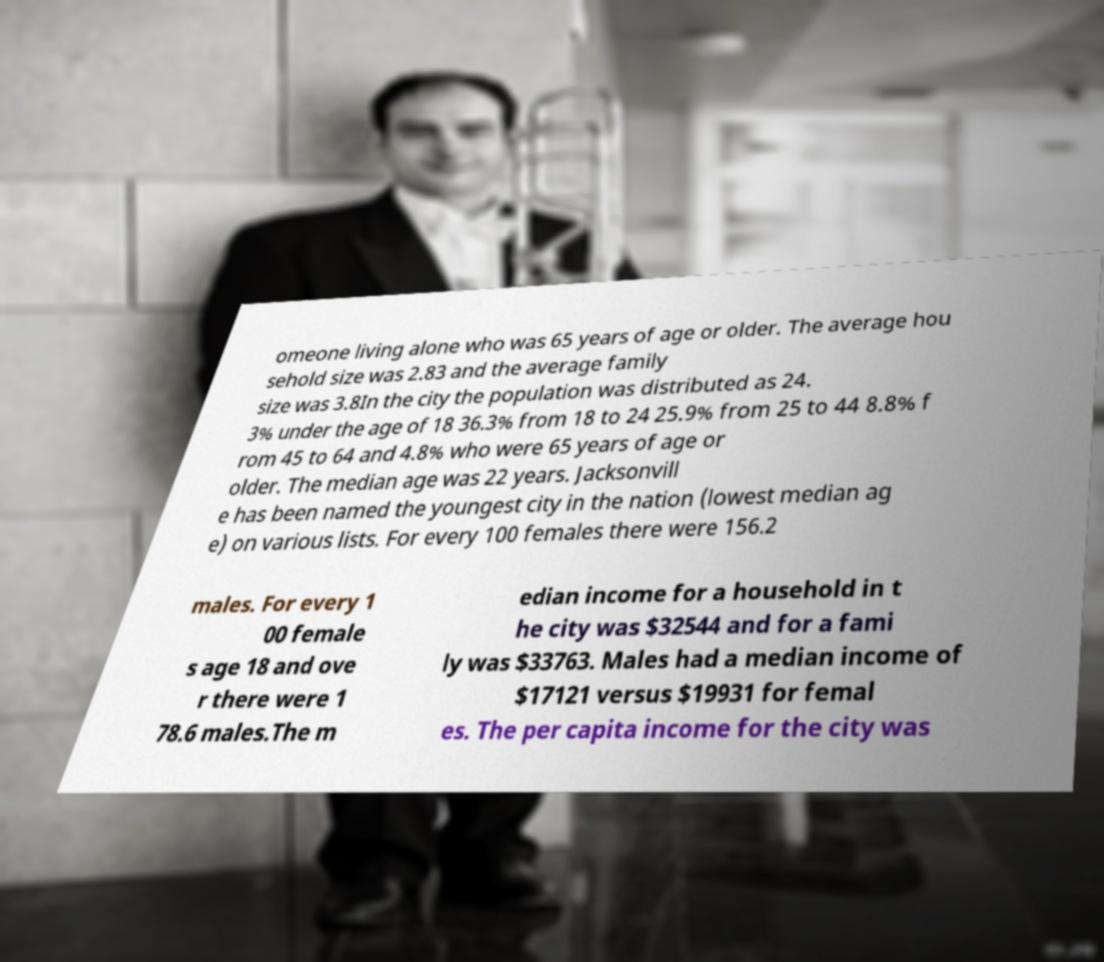Can you read and provide the text displayed in the image?This photo seems to have some interesting text. Can you extract and type it out for me? omeone living alone who was 65 years of age or older. The average hou sehold size was 2.83 and the average family size was 3.8In the city the population was distributed as 24. 3% under the age of 18 36.3% from 18 to 24 25.9% from 25 to 44 8.8% f rom 45 to 64 and 4.8% who were 65 years of age or older. The median age was 22 years. Jacksonvill e has been named the youngest city in the nation (lowest median ag e) on various lists. For every 100 females there were 156.2 males. For every 1 00 female s age 18 and ove r there were 1 78.6 males.The m edian income for a household in t he city was $32544 and for a fami ly was $33763. Males had a median income of $17121 versus $19931 for femal es. The per capita income for the city was 